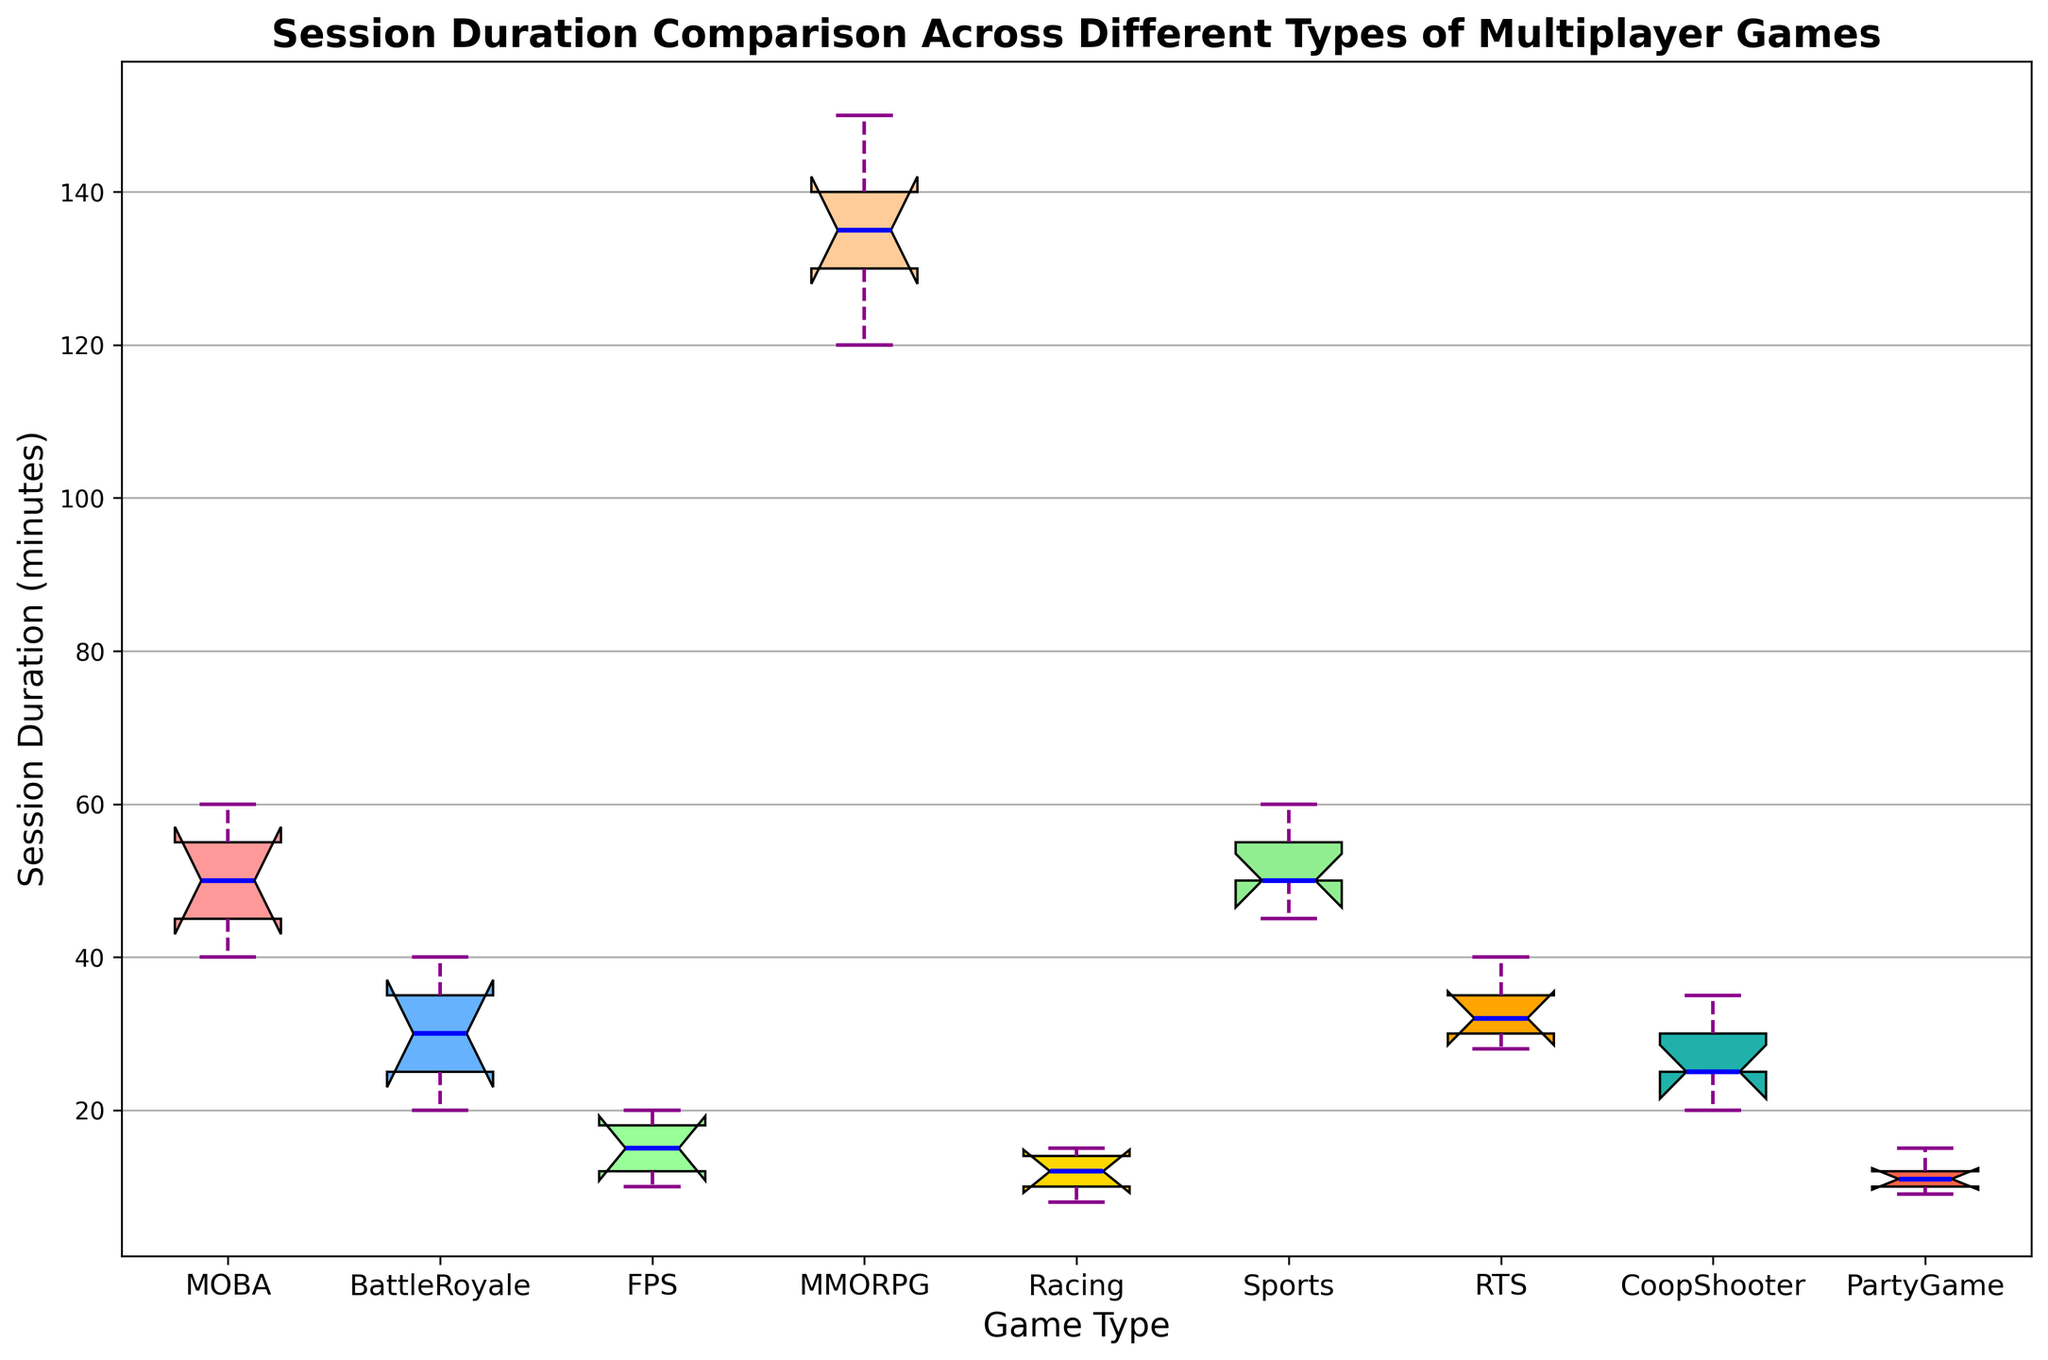Which game type has the highest median session duration? Look for the box plot with the highest median line. MMORPG shows the highest median session duration.
Answer: MMORPG Which game type has the smallest range of session durations? The range of a box plot can be identified by the difference between the top and bottom whiskers. FPS has the smallest range between its whiskers.
Answer: FPS What is the median session duration for Sports games? The median is represented by the line inside the box. For Sports games, it appears to be 50 minutes.
Answer: 50 minutes Compare the interquartile range (IQR) of MOBA and Battle Royale games. Which is larger? The IQR is the range between the top and bottom of the box. MOBA has a larger IQR because its box is taller.
Answer: MOBA Which game types have outliers? Outliers are indicated by points outside the whiskers. MMORPG shows outliers.
Answer: MMORPG How does the median session duration of RTS games compare to Racing games? The median can be seen as the line inside the box. RTS has a higher median session duration compared to Racing games.
Answer: RTS > Racing What is the approximate median session duration for Cooperative Shooter games? The median is the central line within the box. For Cooperative Shooter games, it’s around 25 minutes.
Answer: 25 minutes Which game type has the maximum session duration? Look for the highest whisker or the highest outlier point. MMORPG has the highest session duration.
Answer: MMORPG Is the median session duration for FPS games less than MOBA games? Compare the central lines of the boxes for both FPS and MOBA. The median for FPS is much lower than for MOBA.
Answer: Yes Between Racing and Party Game types, which one has a wider range of session durations? The range is the distance between the top and bottom whiskers. Racing shows a wider range as its whiskers are further apart.
Answer: Racing 